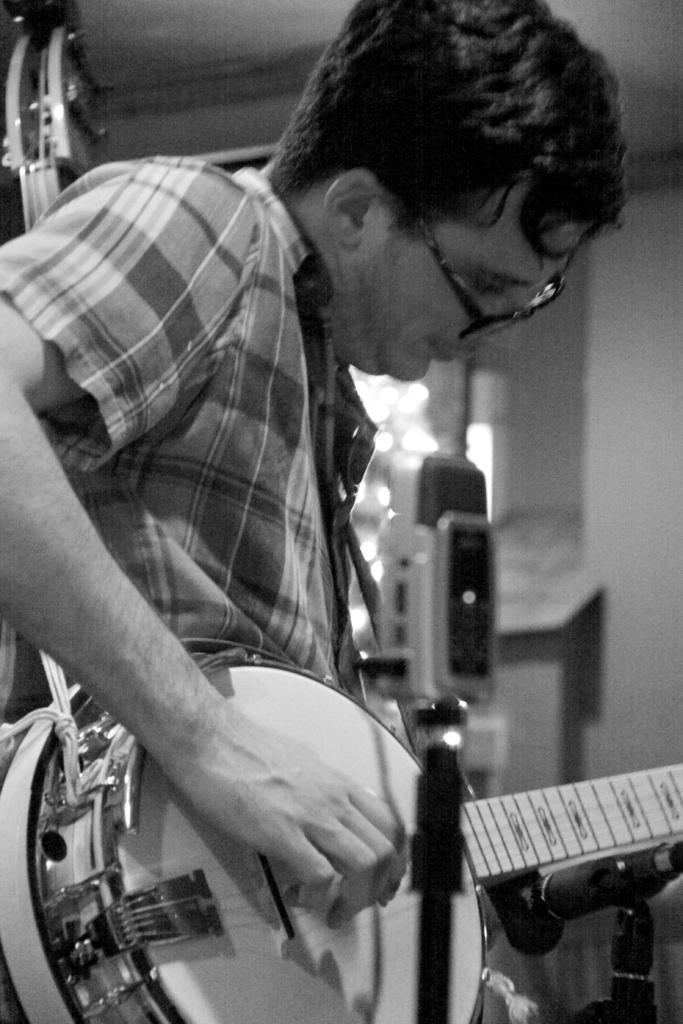Describe this image in one or two sentences. In a given image i can see a person holding a musical instrument. 